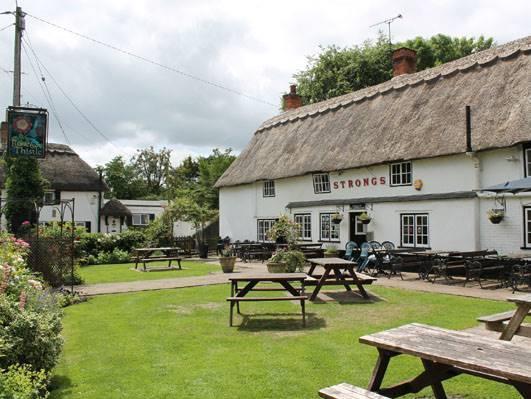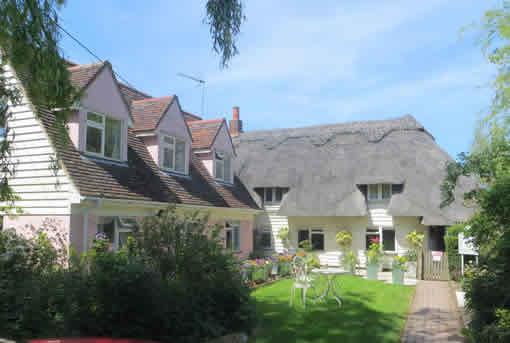The first image is the image on the left, the second image is the image on the right. For the images displayed, is the sentence "A red chimney rises from a yellow building with a thatched roof." factually correct? Answer yes or no. No. 